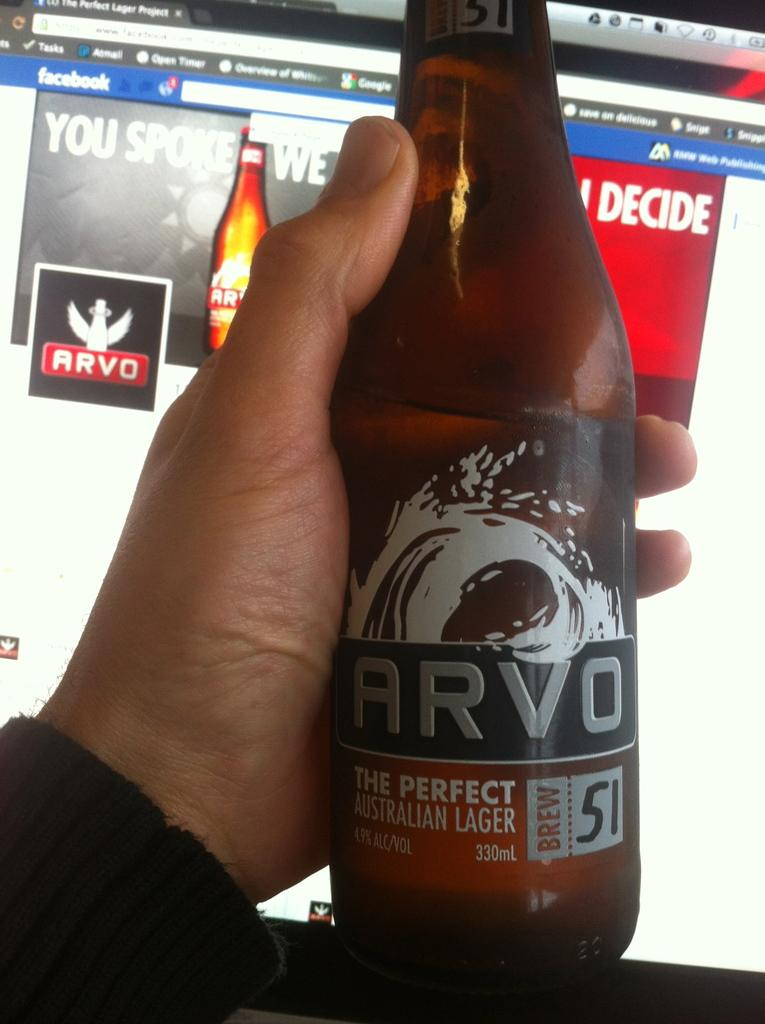What is the main subject of the image? There is a person in the image. What is the person holding in the image? The person is holding a bottle. What can be seen in the background of the bottle? The background of the bottle is a screen. How many rabbits are sitting on the scale in the image? There are no rabbits or scales present in the image. 